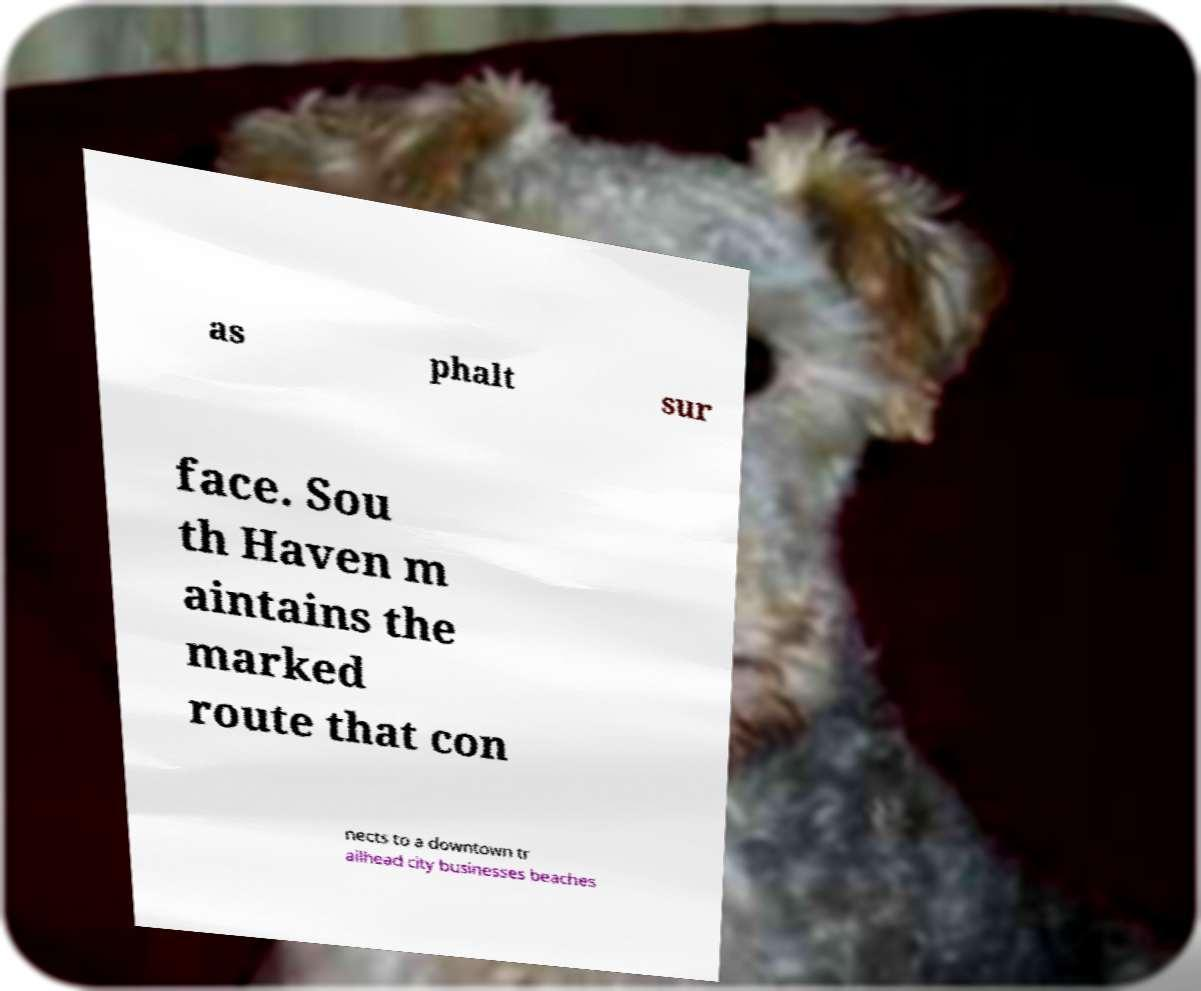Can you accurately transcribe the text from the provided image for me? as phalt sur face. Sou th Haven m aintains the marked route that con nects to a downtown tr ailhead city businesses beaches 